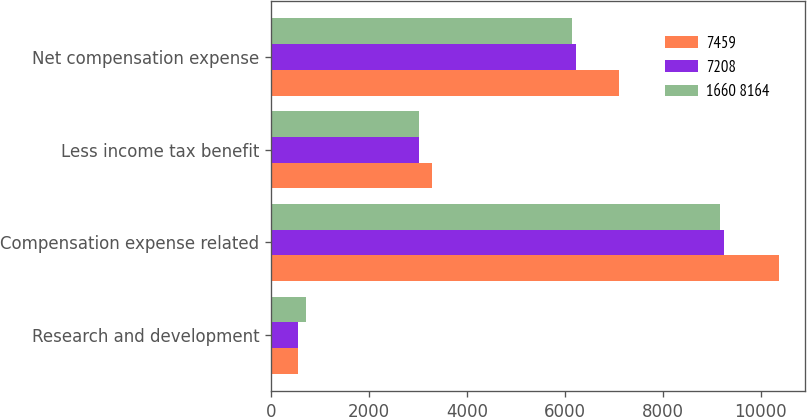Convert chart to OTSL. <chart><loc_0><loc_0><loc_500><loc_500><stacked_bar_chart><ecel><fcel>Research and development<fcel>Compensation expense related<fcel>Less income tax benefit<fcel>Net compensation expense<nl><fcel>7459<fcel>558<fcel>10382<fcel>3285<fcel>7097<nl><fcel>7208<fcel>554<fcel>9246<fcel>3014<fcel>6232<nl><fcel>1660 8164<fcel>708<fcel>9167<fcel>3025<fcel>6142<nl></chart> 